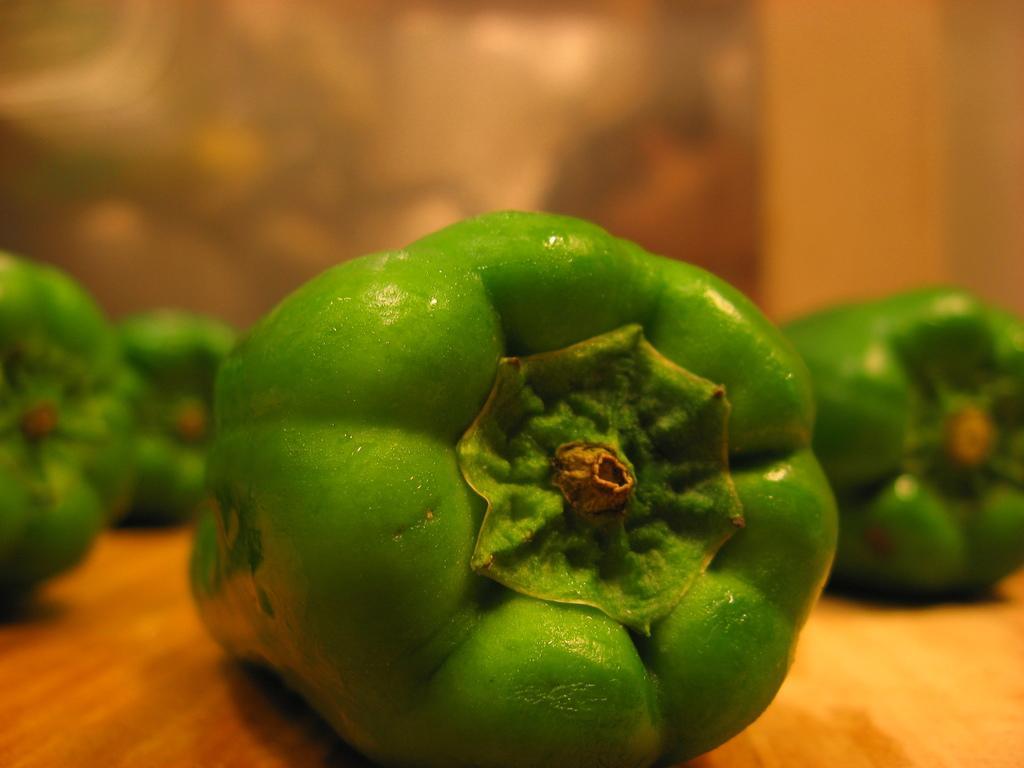Can you describe this image briefly? In this image there are vegetables placed on the surface. The background is blurry. 